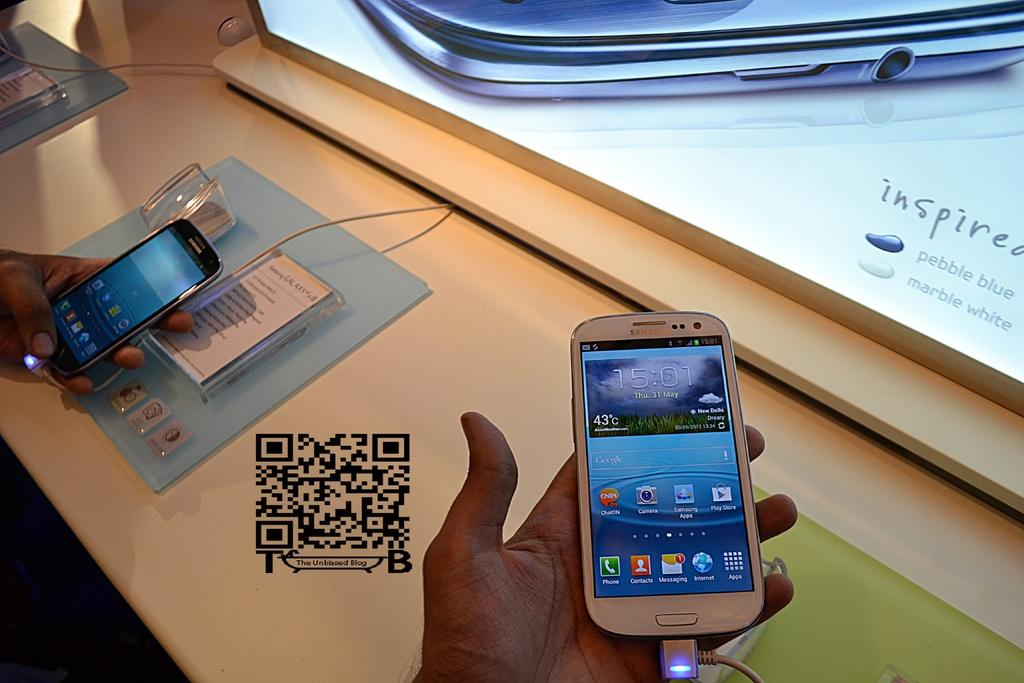<image>
Offer a succinct explanation of the picture presented. People's hands holding display models of Samsung smartphones. 